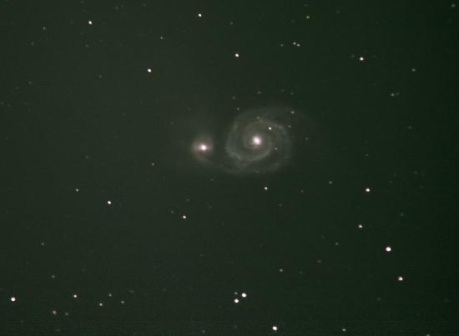Can you tell me more about what a spiral galaxy is? A spiral galaxy is a type of galaxy characterized by its distinct spiral structure, consisting of a flat, rotating disk of stars, gas, and dust, with a concentration of stars at its center known as the bulge and extending outward are the spiral arms. They are often sites of significant cosmic activity, from star formation to complex gravitational interactions. Our own Milky Way is an example of a spiral galaxy, containing billions of stars, with our Solar System located in one of its spiral arms. 